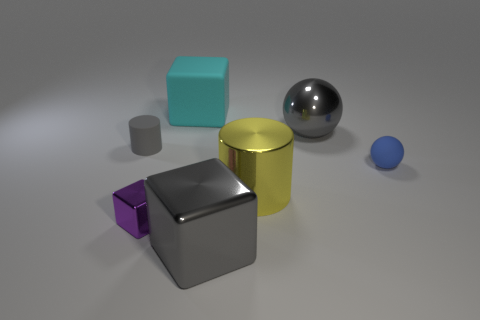What shape is the rubber object behind the large gray sphere?
Your answer should be compact. Cube. What color is the ball that is in front of the large gray object that is behind the blue matte thing?
Give a very brief answer. Blue. What color is the other big thing that is the same shape as the cyan rubber thing?
Give a very brief answer. Gray. What number of cylinders have the same color as the tiny cube?
Ensure brevity in your answer.  0. Do the small shiny cube and the tiny thing that is on the right side of the large cyan matte block have the same color?
Provide a short and direct response. No. The big metal thing that is to the right of the big gray metal block and in front of the small blue matte thing has what shape?
Provide a short and direct response. Cylinder. There is a object in front of the small metal thing in front of the shiny thing behind the small gray cylinder; what is its material?
Ensure brevity in your answer.  Metal. Are there more blue matte spheres to the left of the small blue rubber thing than big gray shiny things left of the shiny cylinder?
Provide a succinct answer. No. What number of tiny red blocks are made of the same material as the tiny blue ball?
Provide a short and direct response. 0. Do the shiny object behind the blue rubber ball and the tiny rubber object that is on the left side of the blue sphere have the same shape?
Provide a succinct answer. No. 